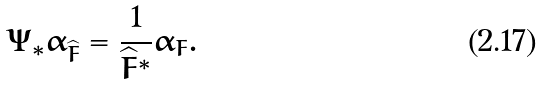<formula> <loc_0><loc_0><loc_500><loc_500>\Psi _ { * } \alpha _ { \widehat { F } } = \frac { 1 } { \widehat { F } ^ { * } } \alpha _ { F } .</formula> 